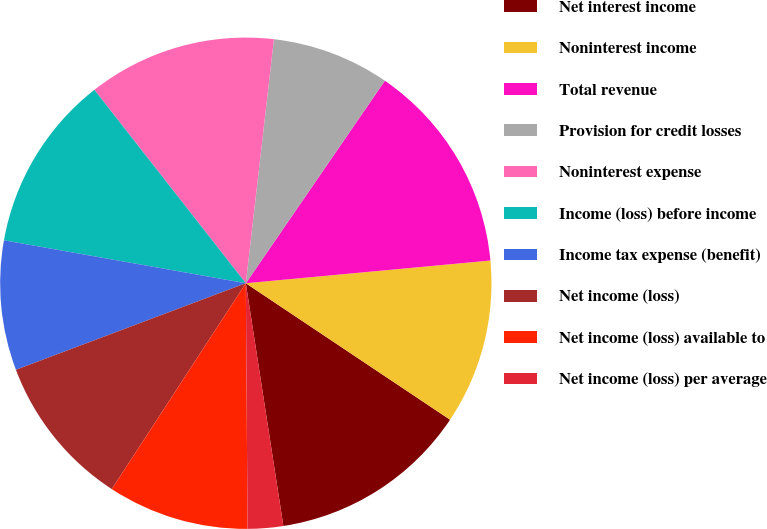Convert chart. <chart><loc_0><loc_0><loc_500><loc_500><pie_chart><fcel>Net interest income<fcel>Noninterest income<fcel>Total revenue<fcel>Provision for credit losses<fcel>Noninterest expense<fcel>Income (loss) before income<fcel>Income tax expense (benefit)<fcel>Net income (loss)<fcel>Net income (loss) available to<fcel>Net income (loss) per average<nl><fcel>13.18%<fcel>10.85%<fcel>13.95%<fcel>7.75%<fcel>12.4%<fcel>11.63%<fcel>8.53%<fcel>10.08%<fcel>9.3%<fcel>2.33%<nl></chart> 